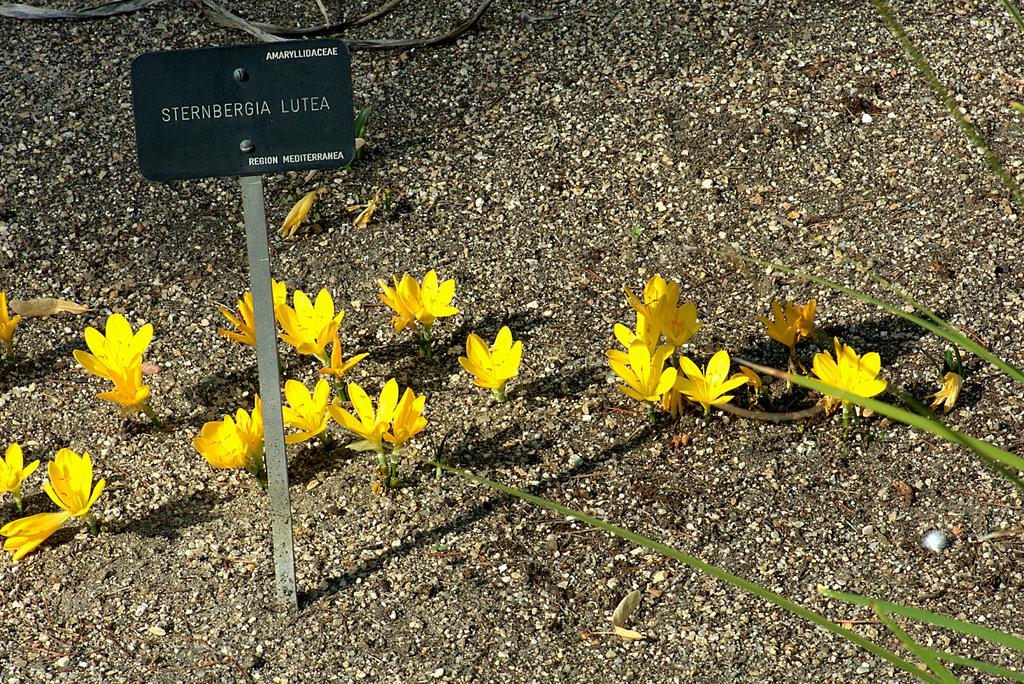What is the main object in the picture? There is a board in the picture. What is on the board? There are flowers on the board. What color are the flowers? The flowers are yellow. What can be seen beneath the board? There is soil visible in the picture. What type of body is visible in the picture? There is no body present in the picture; it features a board with yellow flowers and soil. Can you tell me how many forks are in the picture? There are no forks present in the picture. 